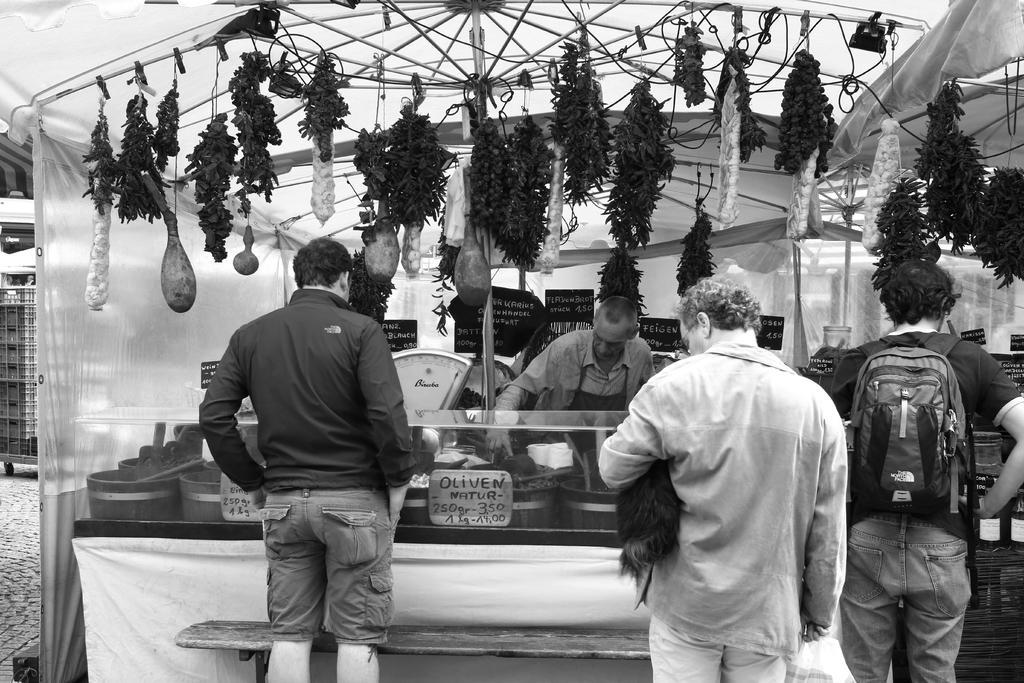Could you give a brief overview of what you see in this image? The image is in black and white, we can see group of persons are standing, in front there is a canopy, there are people selling some items, beside there is a pole, there are few items hanging. 